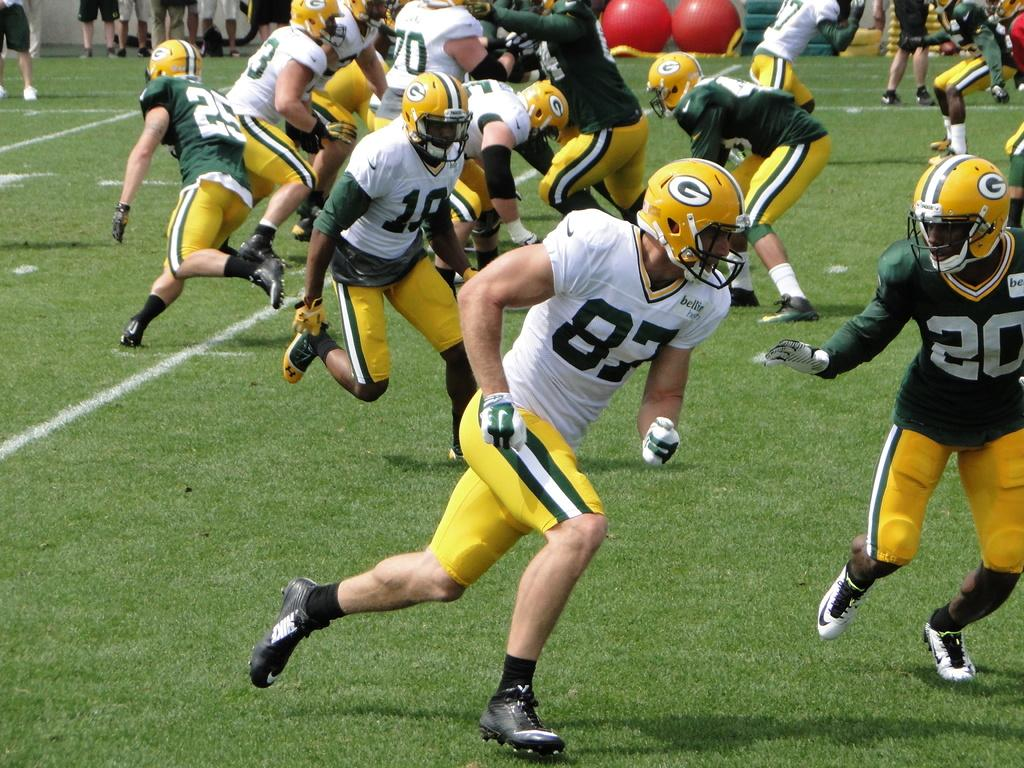What activity are the people engaged in within the image? The people are playing a game in the image. What type of surface are they playing on? There is grass at the bottom of the image. Are there any other people visible in the image? Yes, there are people standing in the background of the image. What type of business is being conducted in the image? There is no indication of any business activity in the image; it features people playing a game on grass. Can you see any fans in the image? There are no fans visible in the image. 